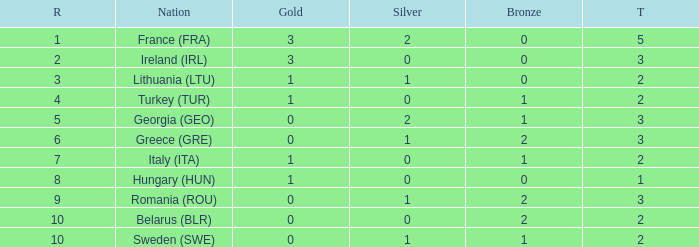What's the total number of bronze medals for Sweden (SWE) having less than 1 gold and silver? 0.0. 